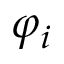<formula> <loc_0><loc_0><loc_500><loc_500>\varphi _ { i }</formula> 